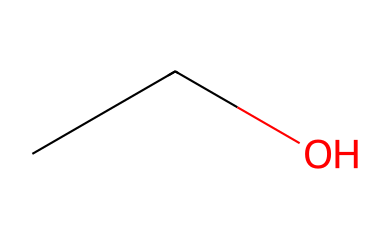What is the name of this chemical? The SMILES representation "CCO" corresponds to ethanol, which is a simple alcohol compound. It consists of a two-carbon chain (eth-) attached to a hydroxyl group (-OH).
Answer: ethanol How many carbon atoms are present? By analyzing the structure represented by "CCO," we can see that there are two carbon atoms in the chain (C and C).
Answer: 2 What type of chemical is it? Ethanol is classified as a non-electrolyte since it does not dissociate into ions in solution. This classification is confirmed by its structure, which contains covalent bonds and lacks ionic character.
Answer: non-electrolyte What is the molecular formula? The chemical structure indicates there are two carbon (C) atoms, six hydrogen (H) atoms, and one oxygen (O) atom, which combine to form the molecular formula C2H6O.
Answer: C2H6O Can this chemical conduct electricity? As a non-electrolyte, ethanol does not dissociate into ions in solution, meaning it cannot conduct electricity. This characteristic stems from its molecular structure, which is fully covalent.
Answer: no What is the functional group present in this chemical? The structure "CCO" shows that it has a hydroxyl group (-OH), which is characteristic of alcohols, specifically making ethanol a primary alcohol.
Answer: hydroxyl group 